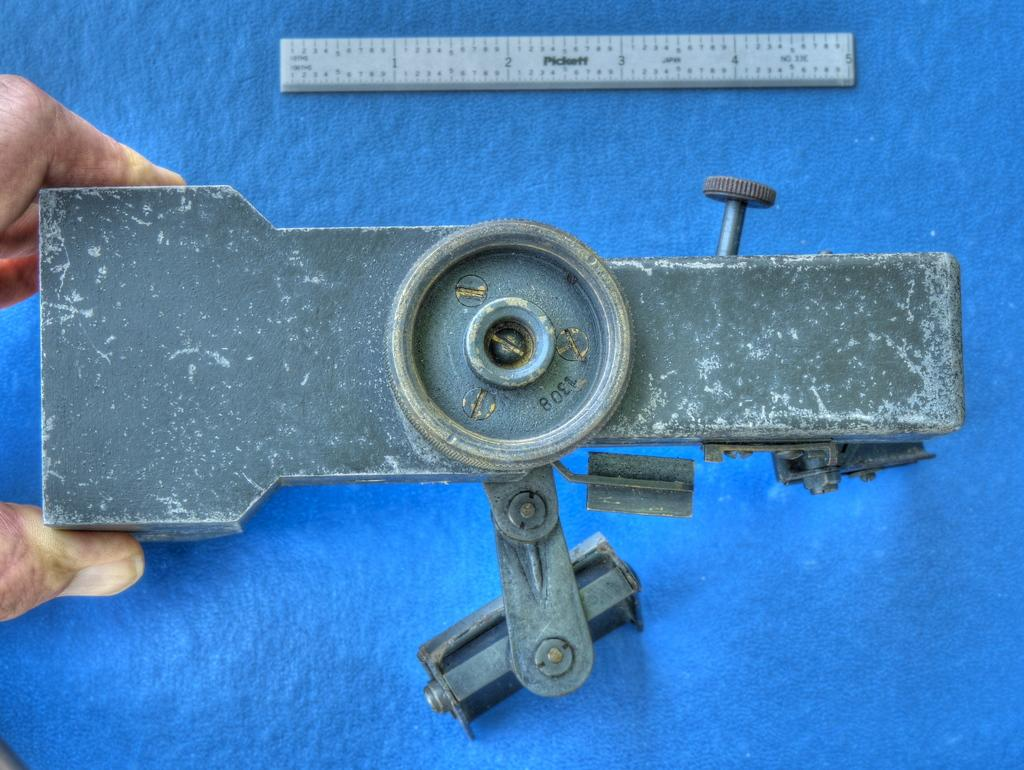<image>
Describe the image concisely. A person holding onto a metal item with a measurement device that goes 1 to 12 